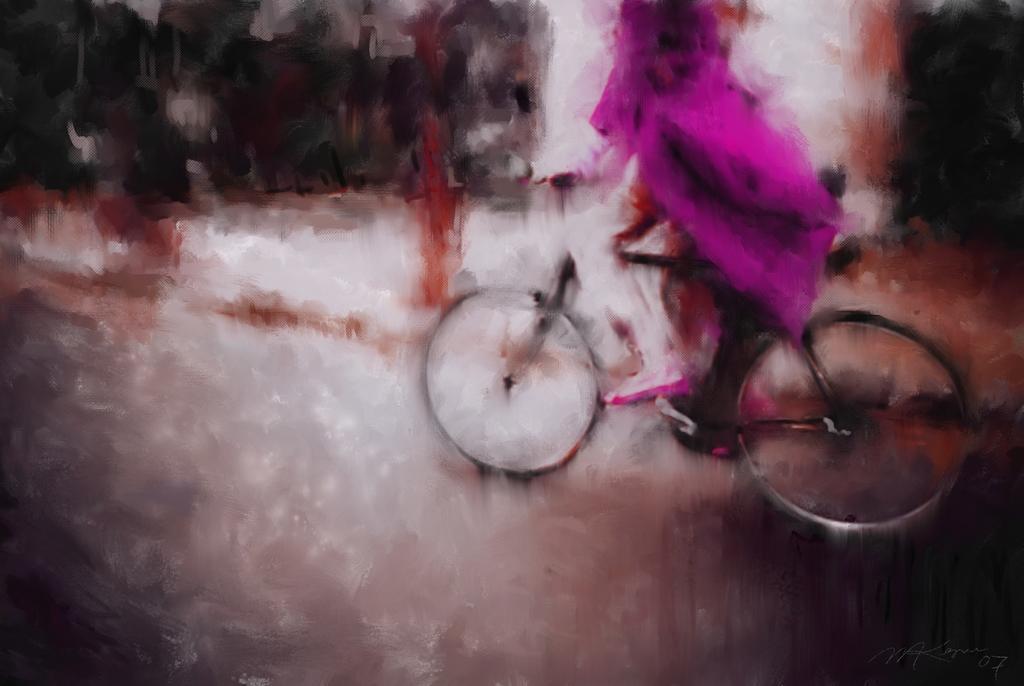Could you give a brief overview of what you see in this image? In the image we can see the painting. In the painting we can see a person riding on the bicycle. 